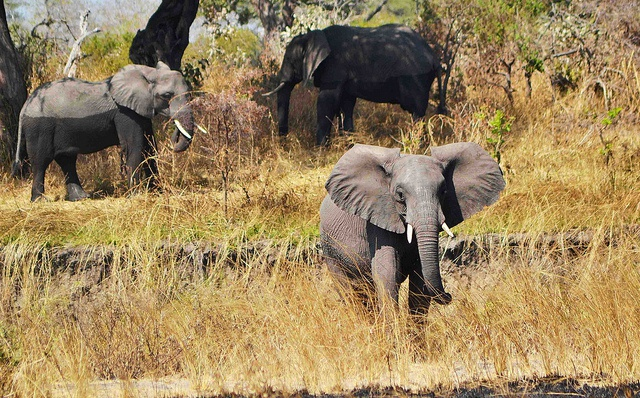Describe the objects in this image and their specific colors. I can see elephant in black, darkgray, and gray tones, elephant in black, darkgray, and gray tones, and elephant in black and gray tones in this image. 